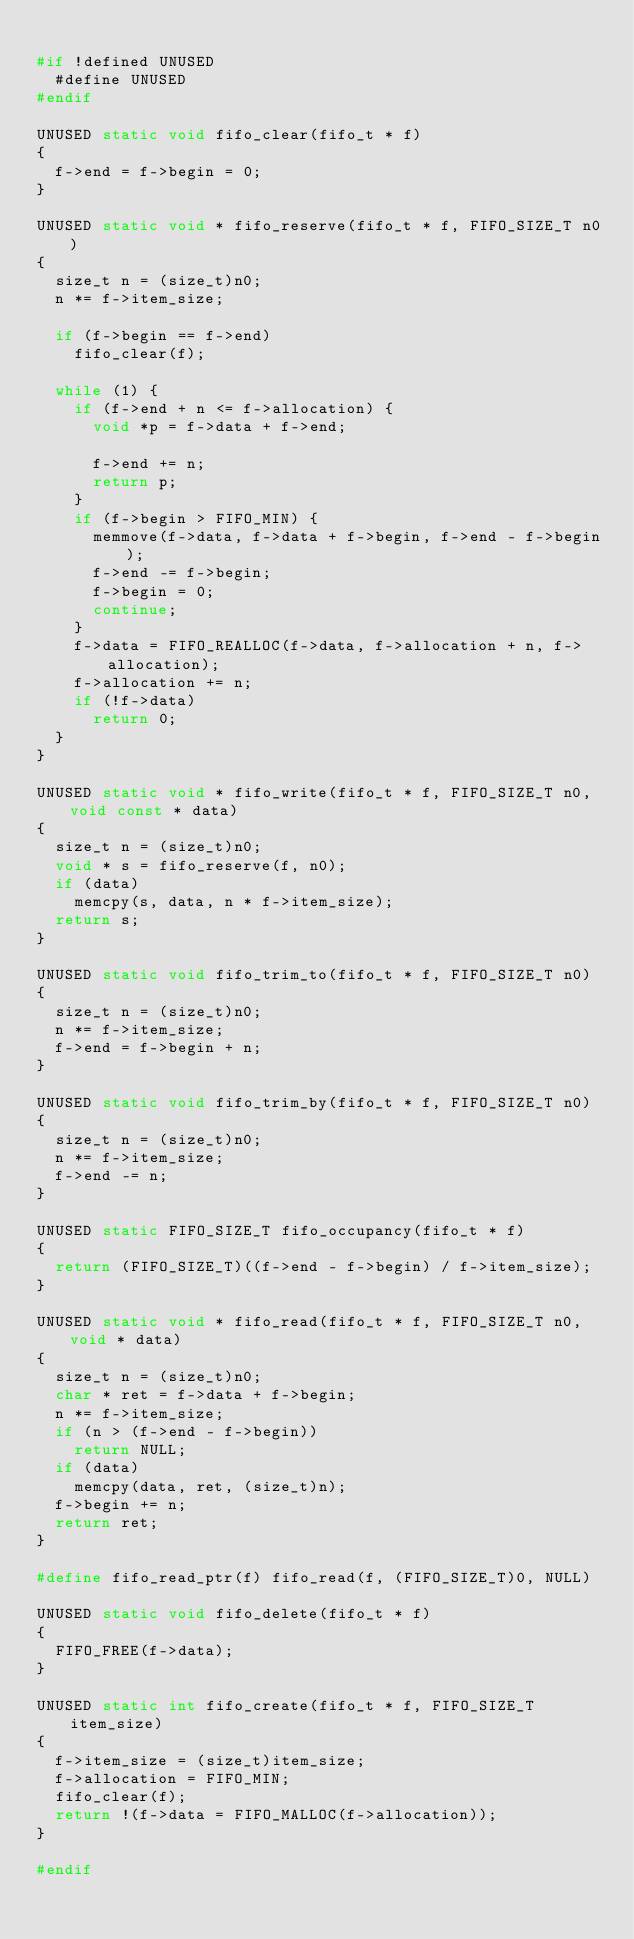<code> <loc_0><loc_0><loc_500><loc_500><_C_>
#if !defined UNUSED
  #define UNUSED
#endif

UNUSED static void fifo_clear(fifo_t * f)
{
  f->end = f->begin = 0;
}

UNUSED static void * fifo_reserve(fifo_t * f, FIFO_SIZE_T n0)
{
  size_t n = (size_t)n0;
  n *= f->item_size;

  if (f->begin == f->end)
    fifo_clear(f);

  while (1) {
    if (f->end + n <= f->allocation) {
      void *p = f->data + f->end;

      f->end += n;
      return p;
    }
    if (f->begin > FIFO_MIN) {
      memmove(f->data, f->data + f->begin, f->end - f->begin);
      f->end -= f->begin;
      f->begin = 0;
      continue;
    }
    f->data = FIFO_REALLOC(f->data, f->allocation + n, f->allocation);
    f->allocation += n;
    if (!f->data)
      return 0;
  }
}

UNUSED static void * fifo_write(fifo_t * f, FIFO_SIZE_T n0, void const * data)
{
  size_t n = (size_t)n0;
  void * s = fifo_reserve(f, n0);
  if (data)
    memcpy(s, data, n * f->item_size);
  return s;
}

UNUSED static void fifo_trim_to(fifo_t * f, FIFO_SIZE_T n0)
{
  size_t n = (size_t)n0;
  n *= f->item_size;
  f->end = f->begin + n;
}

UNUSED static void fifo_trim_by(fifo_t * f, FIFO_SIZE_T n0)
{
  size_t n = (size_t)n0;
  n *= f->item_size;
  f->end -= n;
}

UNUSED static FIFO_SIZE_T fifo_occupancy(fifo_t * f)
{
  return (FIFO_SIZE_T)((f->end - f->begin) / f->item_size);
}

UNUSED static void * fifo_read(fifo_t * f, FIFO_SIZE_T n0, void * data)
{
  size_t n = (size_t)n0;
  char * ret = f->data + f->begin;
  n *= f->item_size;
  if (n > (f->end - f->begin))
    return NULL;
  if (data)
    memcpy(data, ret, (size_t)n);
  f->begin += n;
  return ret;
}

#define fifo_read_ptr(f) fifo_read(f, (FIFO_SIZE_T)0, NULL)

UNUSED static void fifo_delete(fifo_t * f)
{
  FIFO_FREE(f->data);
}

UNUSED static int fifo_create(fifo_t * f, FIFO_SIZE_T item_size)
{
  f->item_size = (size_t)item_size;
  f->allocation = FIFO_MIN;
  fifo_clear(f);
  return !(f->data = FIFO_MALLOC(f->allocation));
}

#endif
</code> 